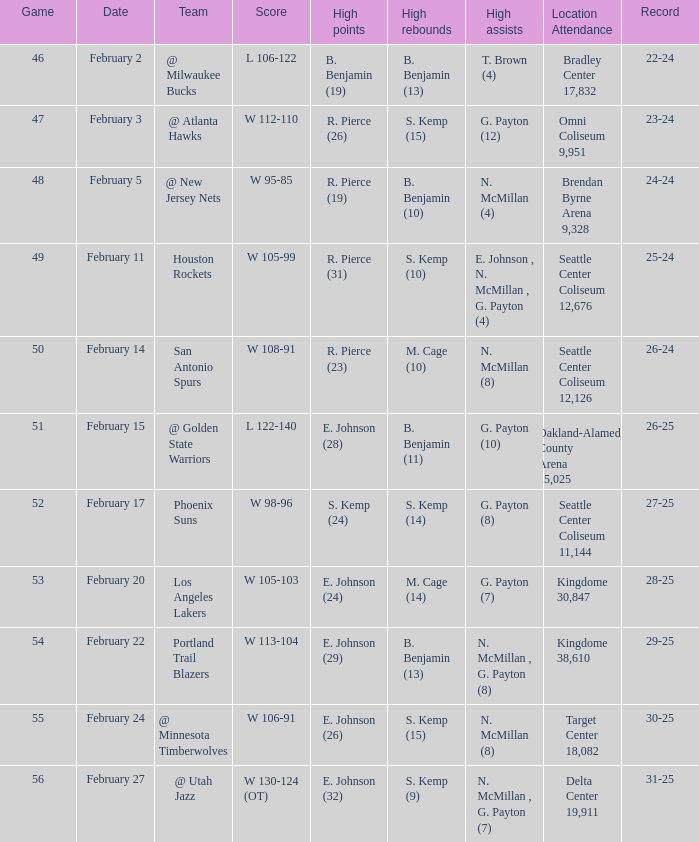What date was the game played in seattle center coliseum 12,126? February 14. 